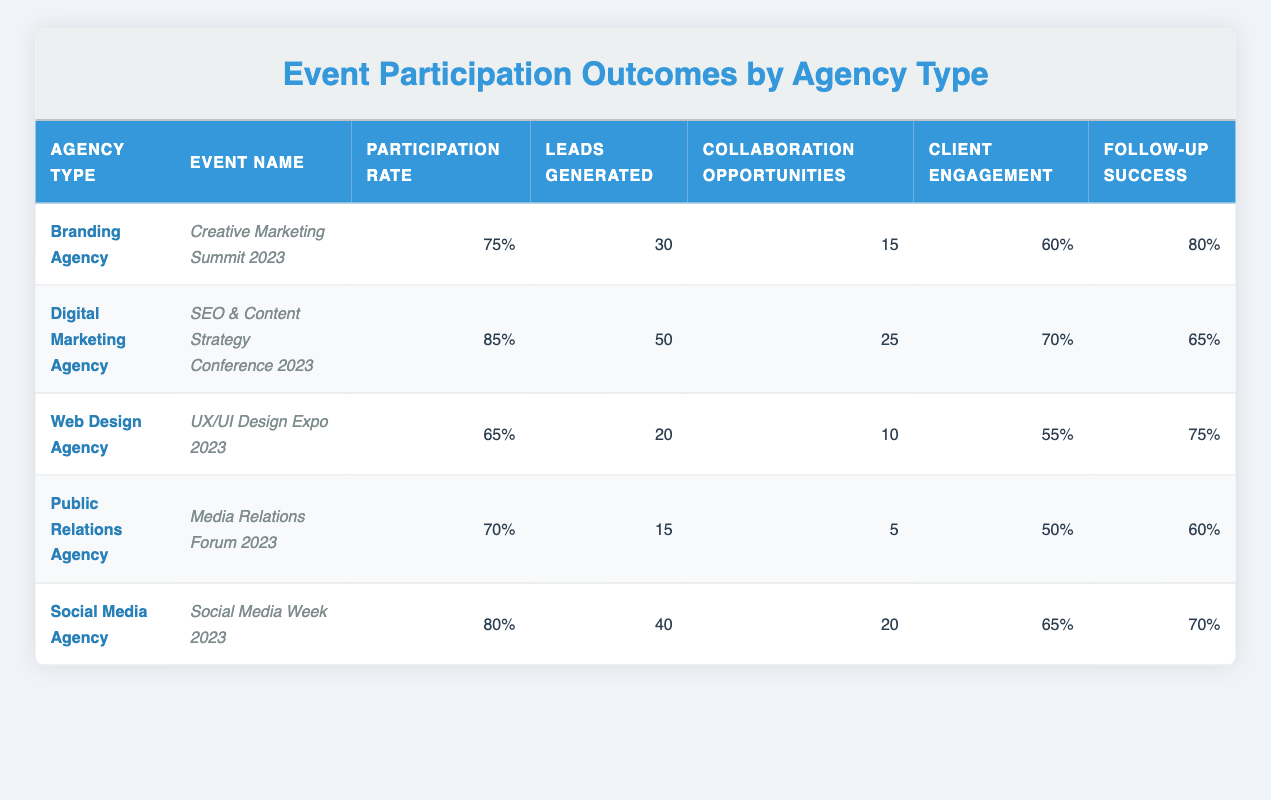What is the participation rate for the Digital Marketing Agency? The participation rate for the Digital Marketing Agency is listed directly in the table under the "Participation Rate" column, specifically for the event "SEO & Content Strategy Conference 2023," which shows a value of 85%.
Answer: 85% Which agency generated the highest number of leads? By looking at the "Leads Generated" column, the Digital Marketing Agency has the highest value of 50 leads, as this is greater than the values listed for all other agency types in the table.
Answer: Digital Marketing Agency What is the average participation rate of all agencies? To find the average participation rate, sum the participation rates (75 + 85 + 65 + 70 + 80 = 375) and divide by the number of agencies (5). The average is 375/5 = 75. Therefore, the average participation rate across all agencies is 75%.
Answer: 75% Is the follow-up success rate for the Branding Agency higher than that of the Web Design Agency? The Branding Agency has a follow-up success rate of 80%, while the Web Design Agency has a rate of 75%. Since 80% is greater than 75%, the statement is true.
Answer: Yes Which agency type has the lowest client engagement? The client engagement rates for each agency type are: Branding Agency (60%), Digital Marketing Agency (70%), Web Design Agency (55%), Public Relations Agency (50%), and Social Media Agency (65%). The lowest value is 50%, associated with the Public Relations Agency.
Answer: Public Relations Agency If you combine the collaboration opportunities of the Branding Agency and Social Media Agency, what is the total? The collaboration opportunities for the Branding Agency is 15 and for the Social Media Agency is 20. Adding these two values gives 15 + 20 = 35.
Answer: 35 What is the follow-up success rate for the agency with the most leads generated? The agency with the most leads generated is the Digital Marketing Agency with 50 leads. Its follow-up success rate is listed as 65%.
Answer: 65% Is there a correlation between participation rate and leads generated based on the table? To analyze, we observe the values: Branding Agency (75% participation, 30 leads), Digital Marketing Agency (85%, 50 leads), Web Design Agency (65%, 20 leads), Public Relations Agency (70%, 15 leads), and Social Media Agency (80%, 40 leads). As participation rates increase, the number of leads also shows an increasing trend, suggesting a positive correlation.
Answer: Yes 